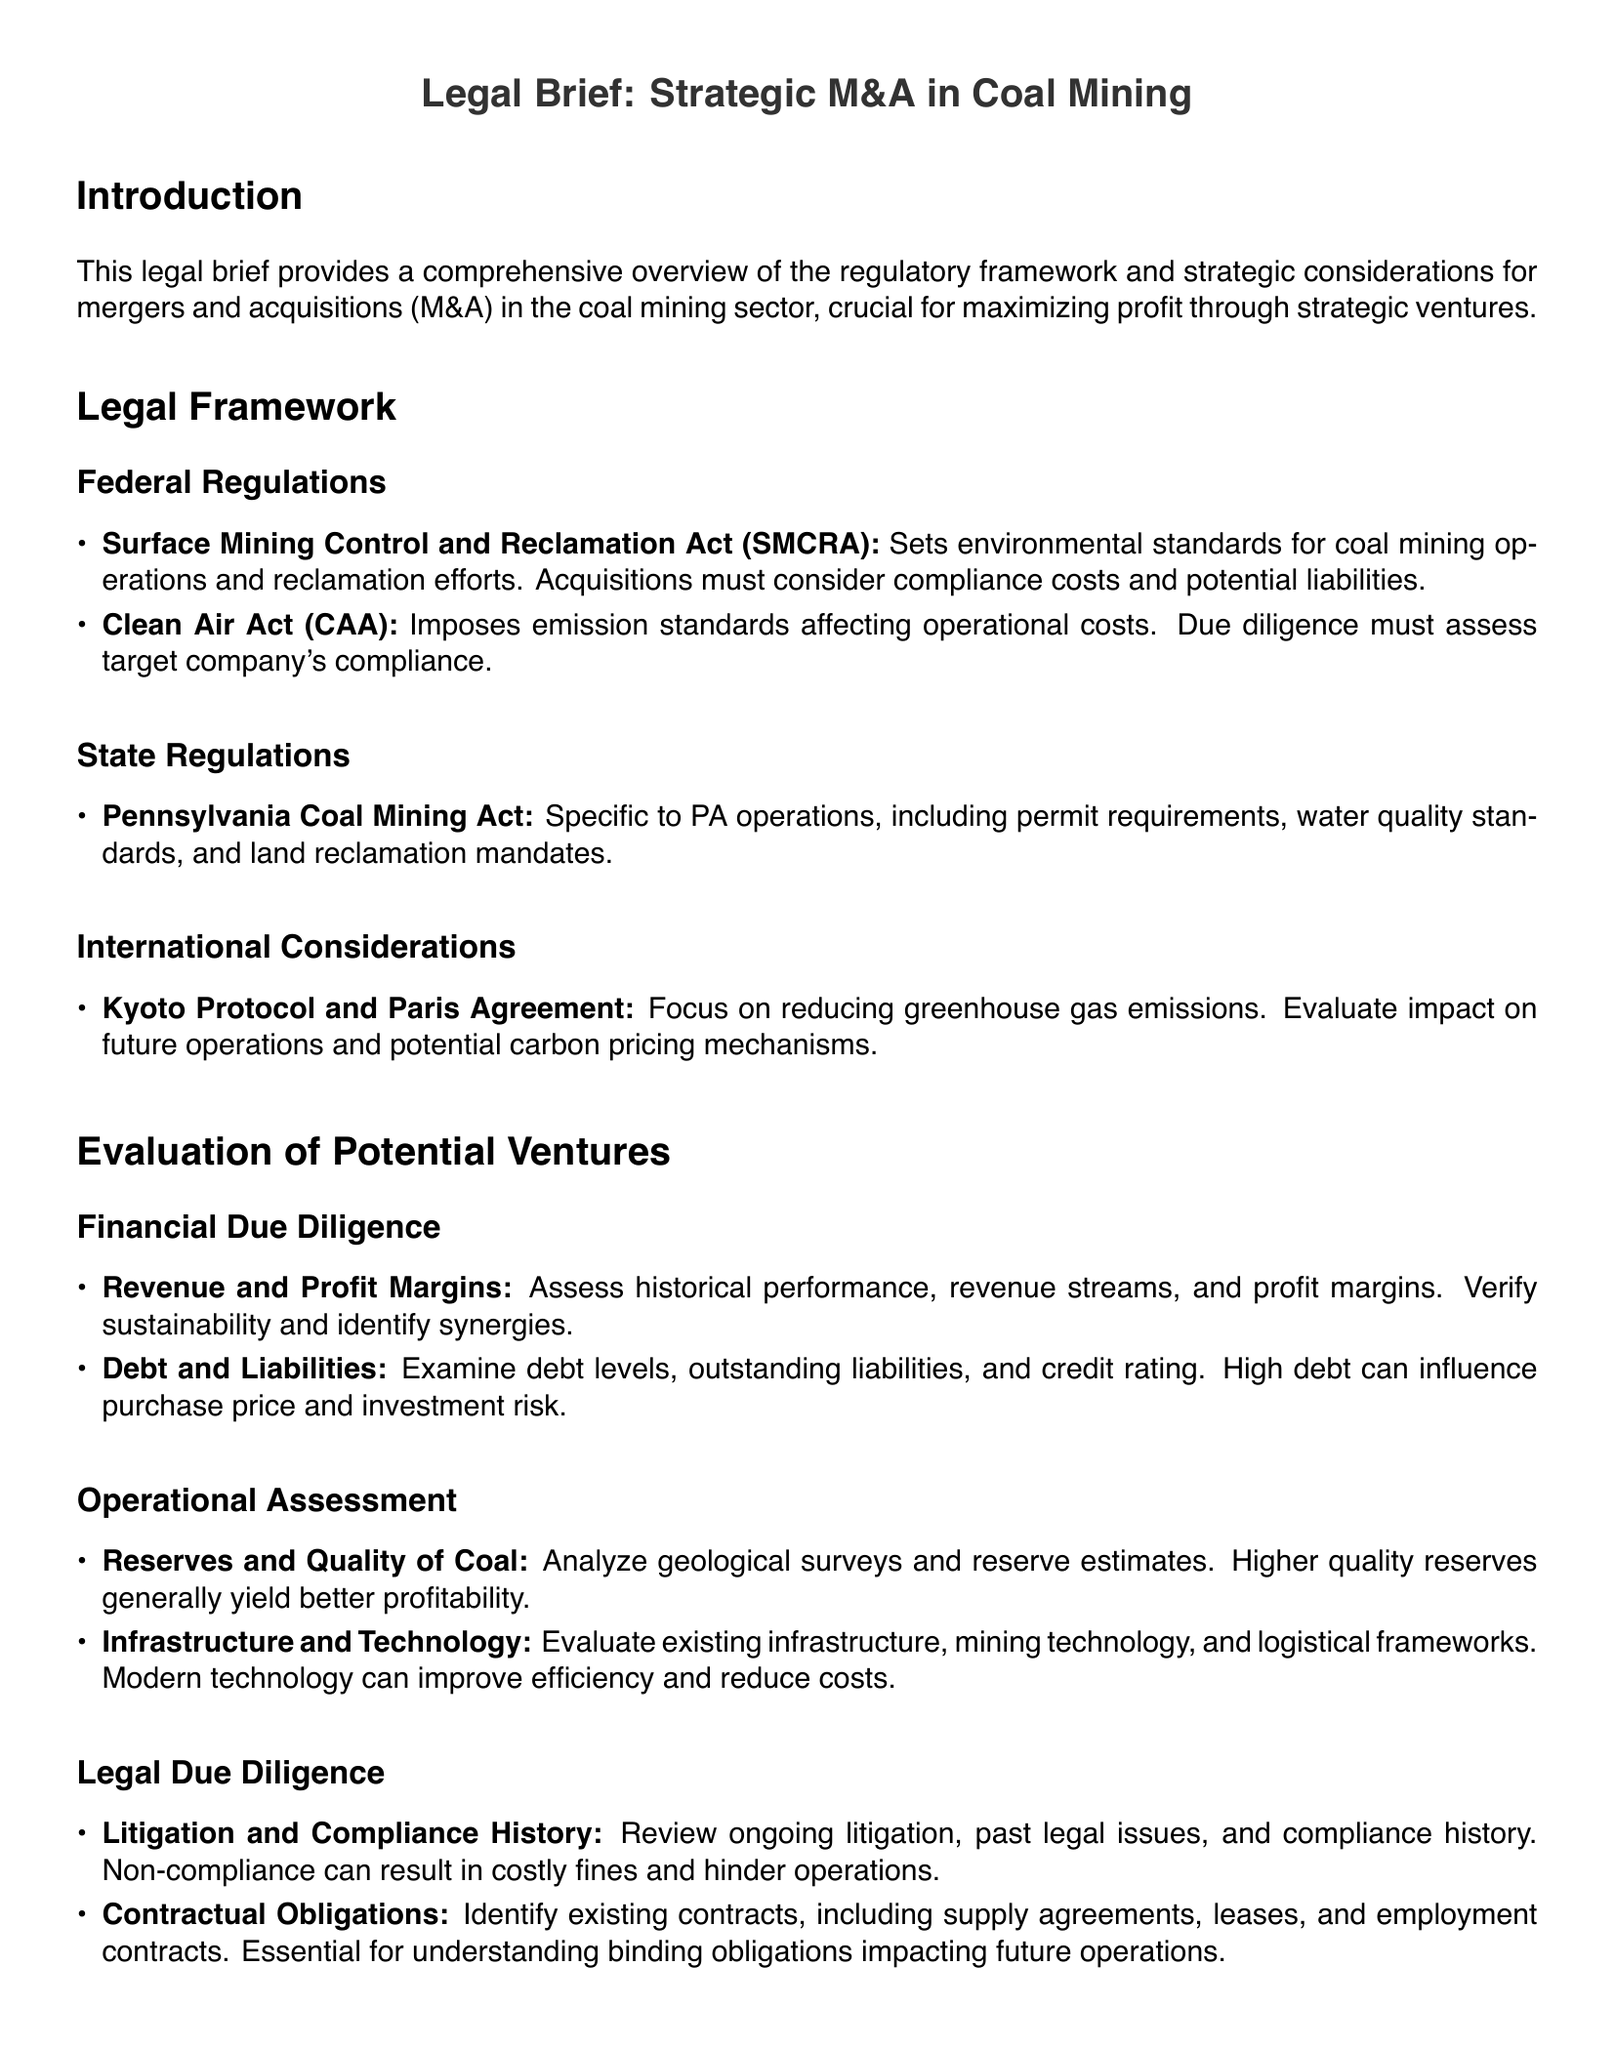what is the primary purpose of the legal brief? The primary purpose of the legal brief is to provide an overview of the regulatory framework and strategic considerations for mergers and acquisitions in the coal mining sector.
Answer: overview of the regulatory framework and strategic considerations which act sets environmental standards for coal mining operations? The Surface Mining Control and Reclamation Act establishes environmental standards for coal mining operations.
Answer: Surface Mining Control and Reclamation Act what must due diligence evaluate in a target company's compliance? Due diligence must assess compliance with the Clean Air Act to understand operational costs.
Answer: Clean Air Act name one financial aspect that needs to be assessed in due diligence. Revenue and profit margins, along with debt and liabilities, are key financial aspects assessed in due diligence.
Answer: Revenue and profit margins what should be analyzed concerning coal reserves? Geological surveys and reserve estimates need to be analyzed for profitability implications.
Answer: geological surveys and reserve estimates which international agreements focus on reducing greenhouse gas emissions? The Kyoto Protocol and Paris Agreement focus on reducing greenhouse gas emissions.
Answer: Kyoto Protocol and Paris Agreement what type of history should be reviewed in legal due diligence? Ongoing litigation and past legal issues should be reviewed to assess compliance history.
Answer: ongoing litigation and past legal issues what does the evaluation of existing infrastructure assess? The evaluation assesses the mining technology and logistical frameworks in place.
Answer: mining technology and logistical frameworks which state's regulations are specifically mentioned in the document? The Pennsylvania Coal Mining Act is specifically mentioned among state regulations.
Answer: Pennsylvania Coal Mining Act 